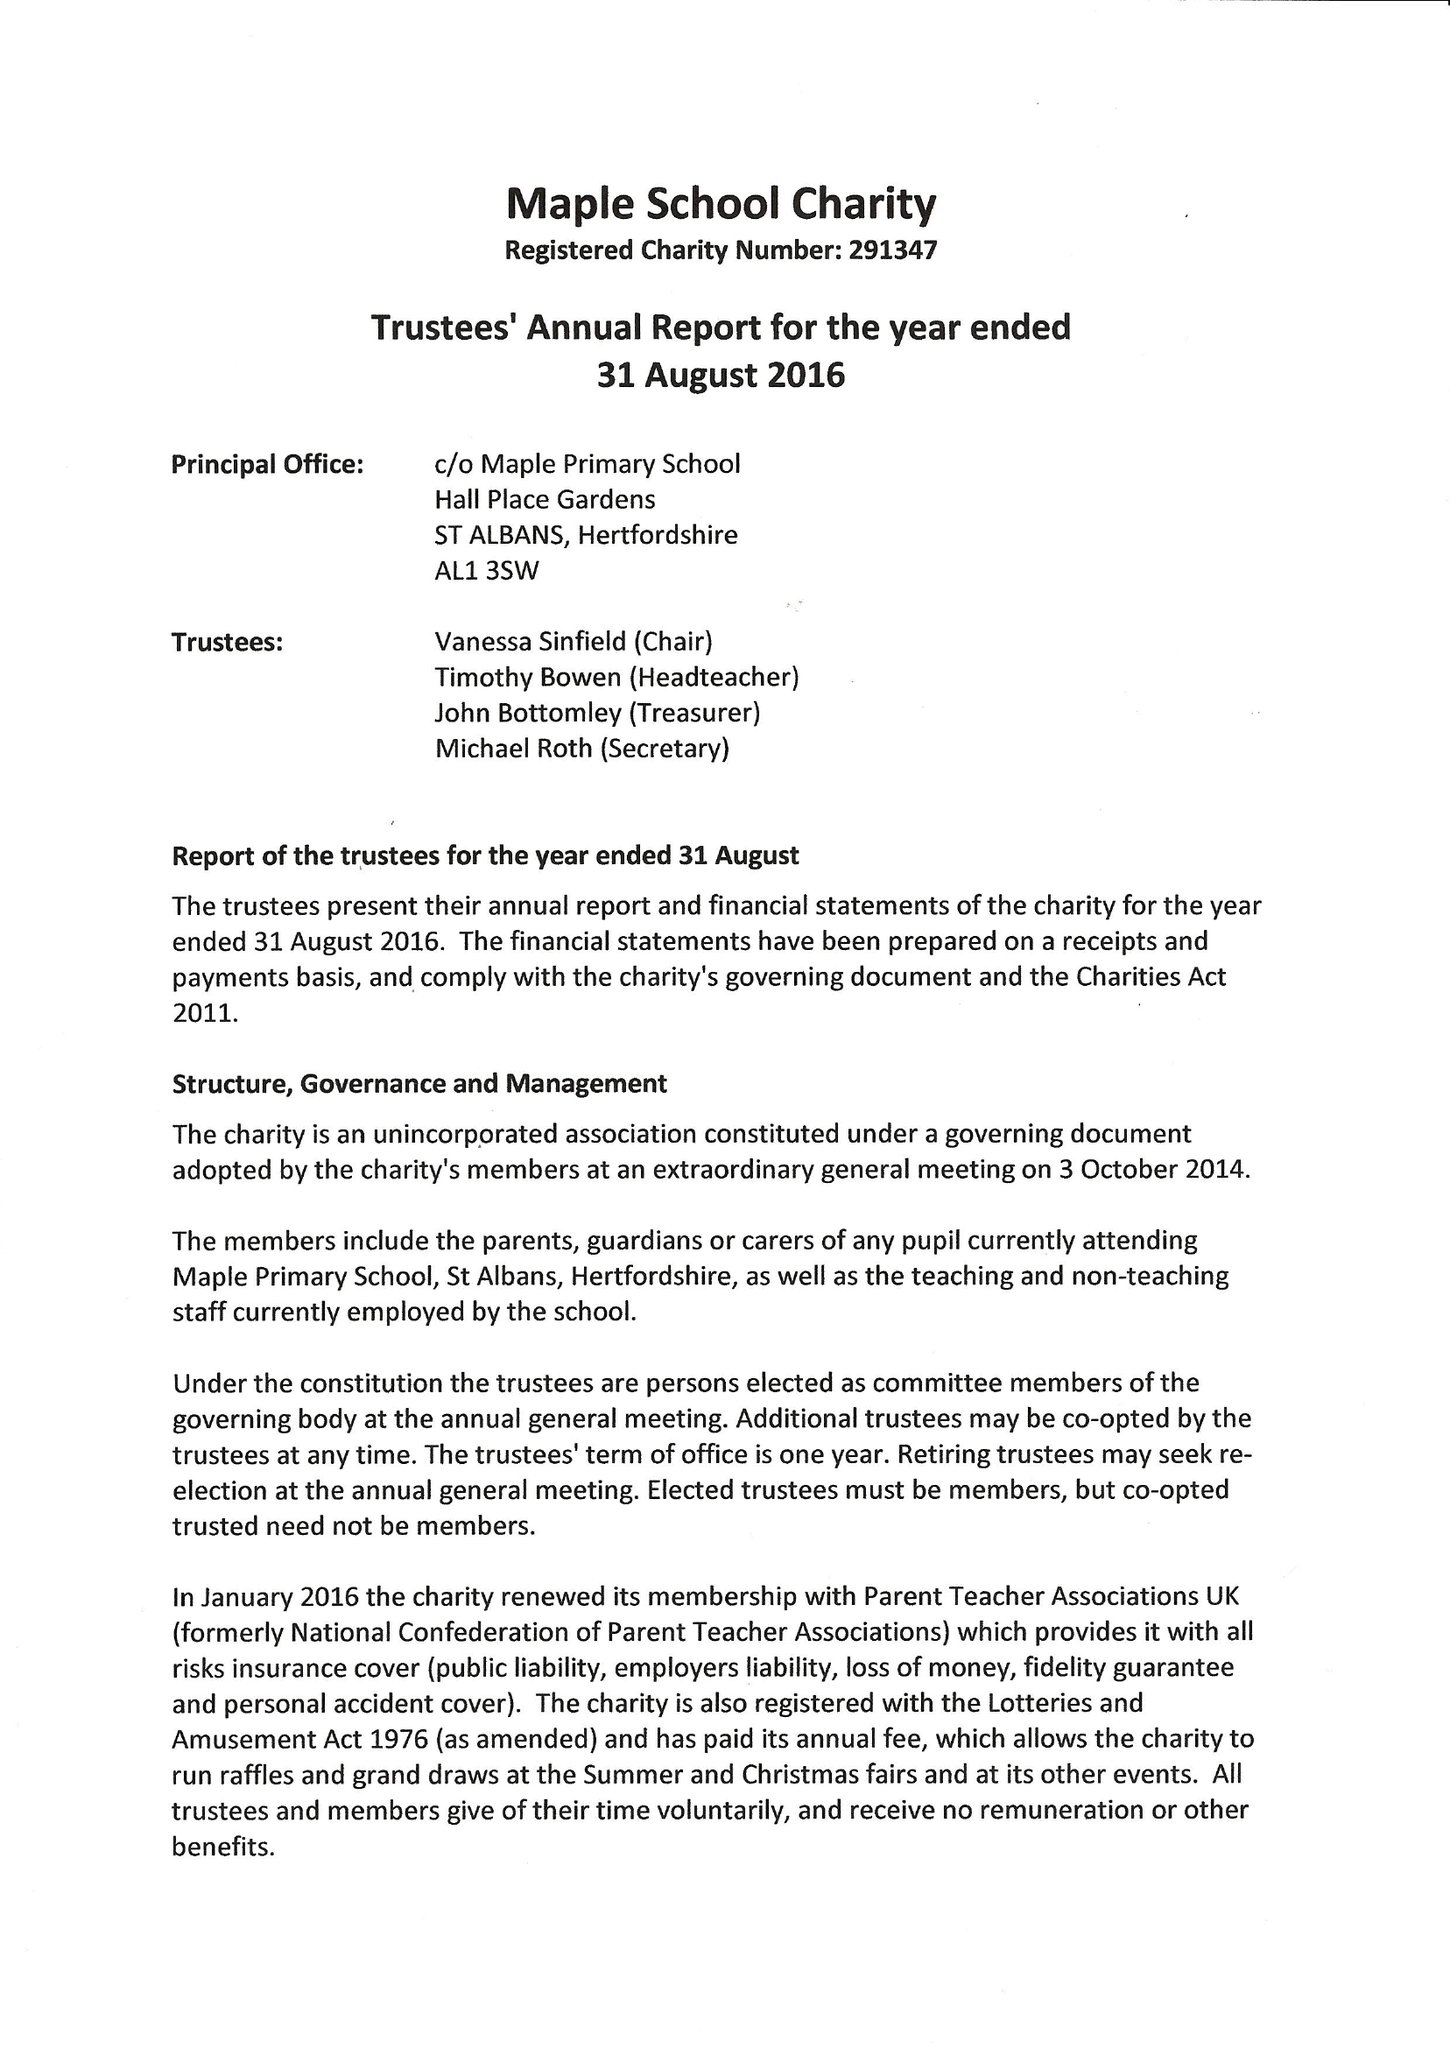What is the value for the report_date?
Answer the question using a single word or phrase. 2016-08-31 